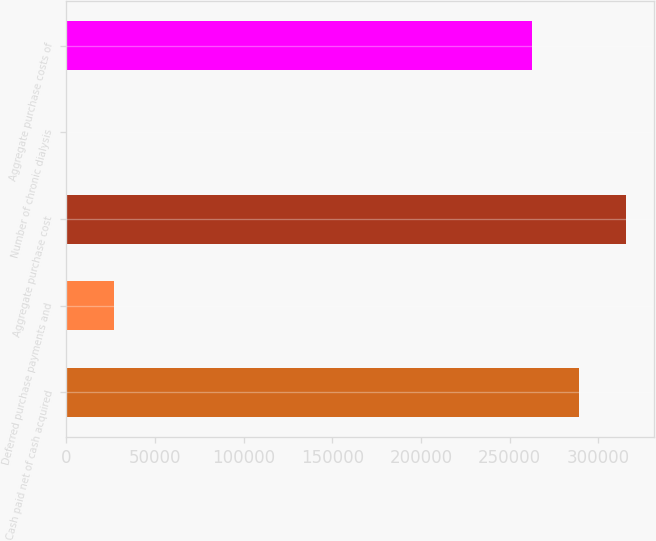<chart> <loc_0><loc_0><loc_500><loc_500><bar_chart><fcel>Cash paid net of cash acquired<fcel>Deferred purchase payments and<fcel>Aggregate purchase cost<fcel>Number of chronic dialysis<fcel>Aggregate purchase costs of<nl><fcel>289122<fcel>26715.3<fcel>315787<fcel>51<fcel>262458<nl></chart> 